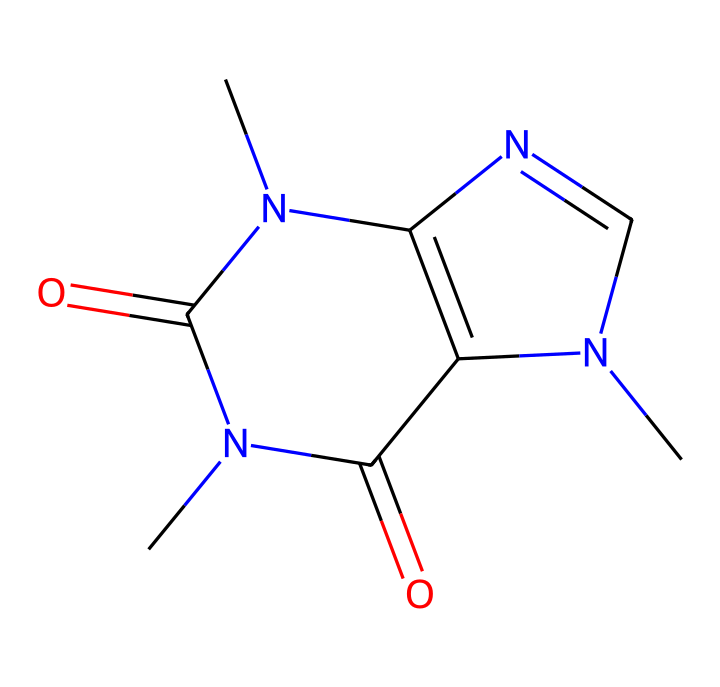What is the molecular formula of this compound? By analyzing the SMILES representation, we can identify the elements present: there are 8 carbon atoms (C), 10 hydrogen atoms (H), 4 nitrogen atoms (N), and 2 oxygen atoms (O). Thus, the molecular formula can be deduced as C8H10N4O2.
Answer: C8H10N4O2 How many ring structures are present in this chemical? From the SMILES notation, we can see two 'n' atoms which indicate nitrogen in the ring structure. There are also carbon atoms linked in a cyclic manner, suggesting that there are two ring systems. Counting the rings confirms there's two.
Answer: 2 What is the primary functional group in this chemical? Looking at the SMILES structure, the presence of carbonyls (C=O) indicates that this compound has amide functional groups. This is critical in pharmacochemistry as these groups can influence binding affinity and solubility.
Answer: amide Does this drug contain any heteroatoms? The presence of 'N' and 'O' in the SMILES indicates the inclusion of nitrogen and oxygen atoms, which are known as heteroatoms. These atoms are essential in creating the drug's effective properties and its interaction with biological targets.
Answer: yes What type of drug classification does this compound fall under? Based on the presence of stimulant effects commonly associated with compounds that contain nitrogen and the structure resembling that of psychoactive substances, this compound is classified as a stimulant.
Answer: stimulant Which specific nitrogen atoms contribute to the compound's stimulant effects? The attached nitrogen atoms (specifically the ones connected to carbon atoms within the rings of this structure) are important for the drug's mechanism of action and are known to affect adenosine receptors in the brain, which contributes to the stimulant properties.
Answer: nitrogen atoms in the rings 